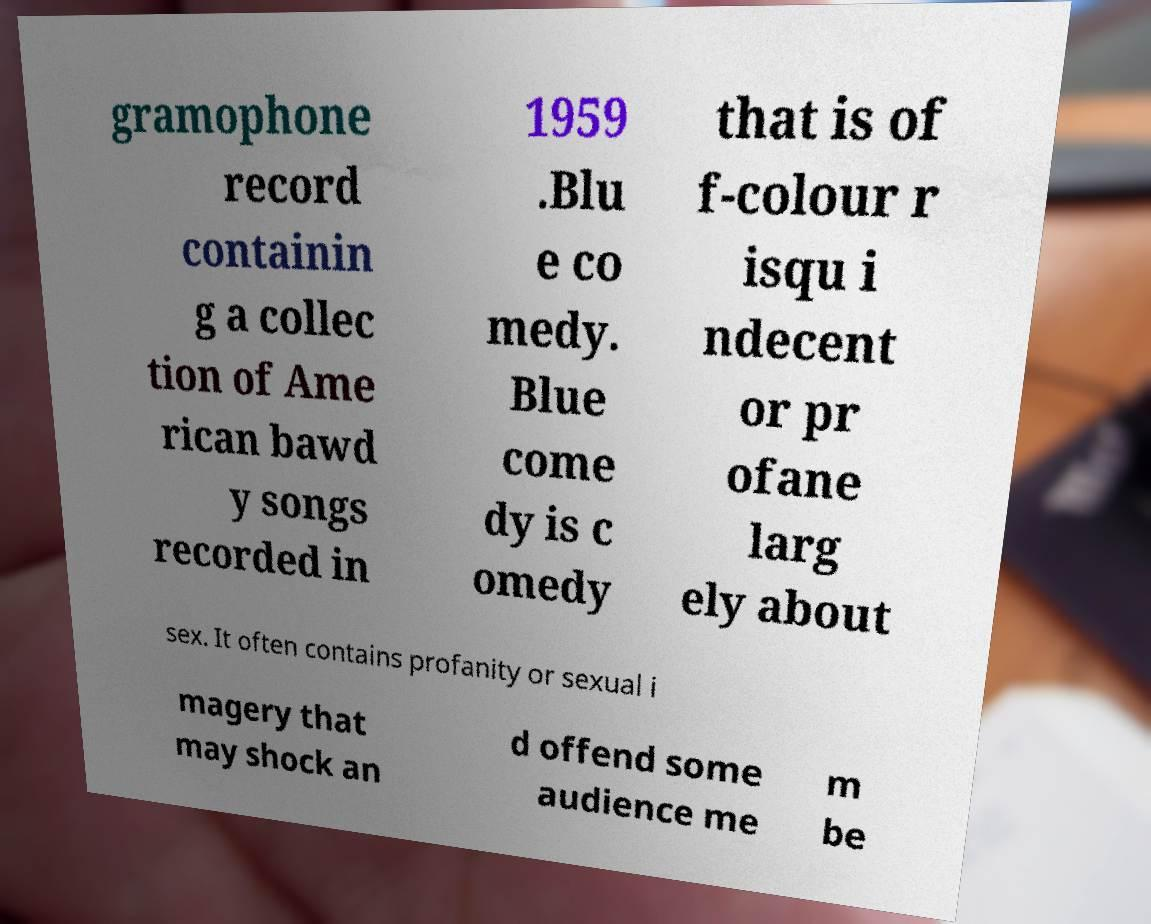I need the written content from this picture converted into text. Can you do that? gramophone record containin g a collec tion of Ame rican bawd y songs recorded in 1959 .Blu e co medy. Blue come dy is c omedy that is of f-colour r isqu i ndecent or pr ofane larg ely about sex. It often contains profanity or sexual i magery that may shock an d offend some audience me m be 